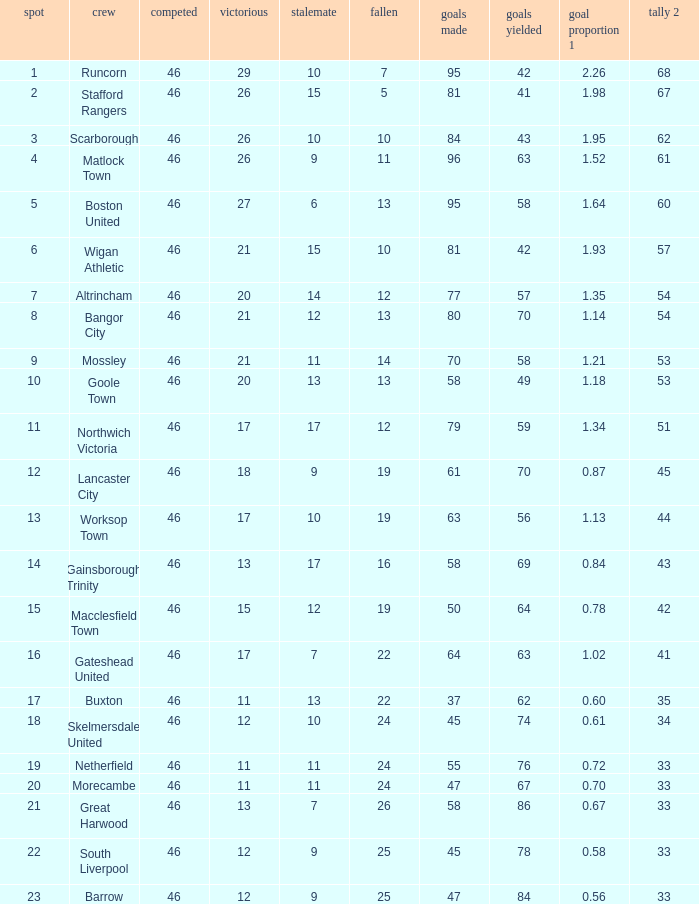List all losses with average goals of 1.21. 14.0. 